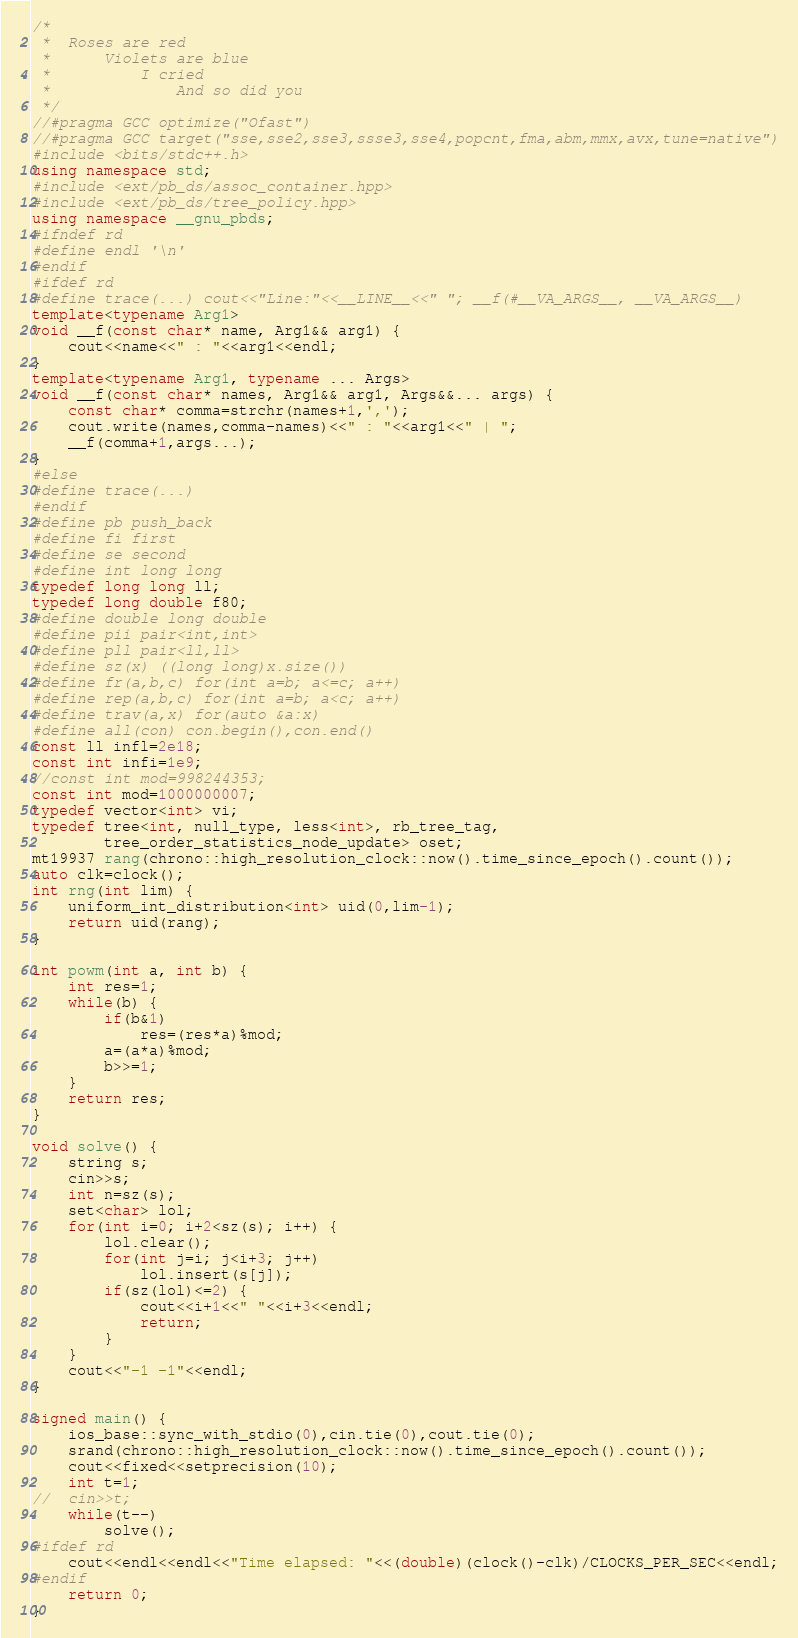Convert code to text. <code><loc_0><loc_0><loc_500><loc_500><_C++_>/*
 * 	Roses are red
 * 		Violets are blue
 * 			I cried
 * 				And so did you
 */
//#pragma GCC optimize("Ofast")
//#pragma GCC target("sse,sse2,sse3,ssse3,sse4,popcnt,fma,abm,mmx,avx,tune=native")
#include <bits/stdc++.h>
using namespace std;
#include <ext/pb_ds/assoc_container.hpp>
#include <ext/pb_ds/tree_policy.hpp>
using namespace __gnu_pbds;
#ifndef rd
#define endl '\n'
#endif
#ifdef rd
#define trace(...) cout<<"Line:"<<__LINE__<<" "; __f(#__VA_ARGS__, __VA_ARGS__)
template<typename Arg1>
void __f(const char* name, Arg1&& arg1) {
	cout<<name<<" : "<<arg1<<endl;
}
template<typename Arg1, typename ... Args>
void __f(const char* names, Arg1&& arg1, Args&&... args) {
	const char* comma=strchr(names+1,',');
	cout.write(names,comma-names)<<" : "<<arg1<<" | ";
	__f(comma+1,args...);
}
#else
#define trace(...)
#endif
#define pb push_back
#define fi first
#define se second
#define int long long
typedef long long ll;
typedef long double f80;
#define double long double
#define pii pair<int,int>
#define pll pair<ll,ll>
#define sz(x) ((long long)x.size())
#define fr(a,b,c) for(int a=b; a<=c; a++)
#define rep(a,b,c) for(int a=b; a<c; a++)
#define trav(a,x) for(auto &a:x)
#define all(con) con.begin(),con.end()
const ll infl=2e18;
const int infi=1e9;
//const int mod=998244353;
const int mod=1000000007;
typedef vector<int> vi;
typedef tree<int, null_type, less<int>, rb_tree_tag,
		tree_order_statistics_node_update> oset;
mt19937 rang(chrono::high_resolution_clock::now().time_since_epoch().count());
auto clk=clock();
int rng(int lim) {
	uniform_int_distribution<int> uid(0,lim-1);
	return uid(rang);
}

int powm(int a, int b) {
	int res=1;
	while(b) {
		if(b&1)
			res=(res*a)%mod;
		a=(a*a)%mod;
		b>>=1;
	}
	return res;
}

void solve() {
	string s;
	cin>>s;
	int n=sz(s);
	set<char> lol;
	for(int i=0; i+2<sz(s); i++) {
		lol.clear();
		for(int j=i; j<i+3; j++)
			lol.insert(s[j]);
		if(sz(lol)<=2) {
			cout<<i+1<<" "<<i+3<<endl;
			return;
		}
	}
	cout<<"-1 -1"<<endl;
}

signed main() {
	ios_base::sync_with_stdio(0),cin.tie(0),cout.tie(0);
	srand(chrono::high_resolution_clock::now().time_since_epoch().count());
	cout<<fixed<<setprecision(10);
	int t=1;
//	cin>>t;
	while(t--)
		solve();
#ifdef rd
	cout<<endl<<endl<<"Time elapsed: "<<(double)(clock()-clk)/CLOCKS_PER_SEC<<endl;
#endif
	return 0;
}
</code> 